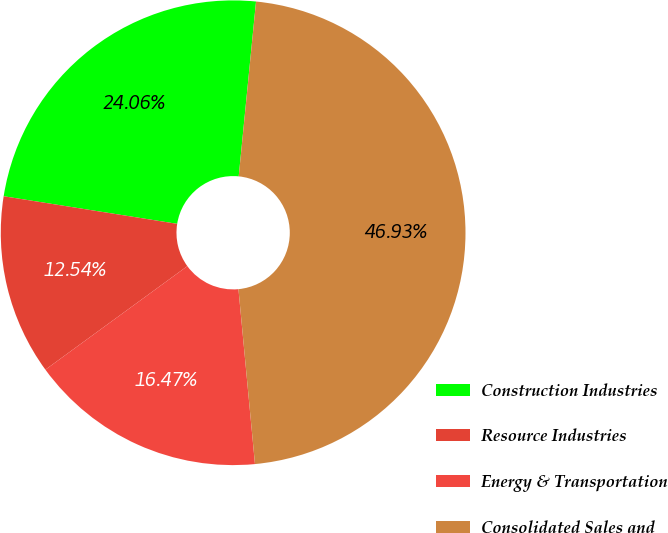Convert chart. <chart><loc_0><loc_0><loc_500><loc_500><pie_chart><fcel>Construction Industries<fcel>Resource Industries<fcel>Energy & Transportation<fcel>Consolidated Sales and<nl><fcel>24.06%<fcel>12.54%<fcel>16.47%<fcel>46.93%<nl></chart> 